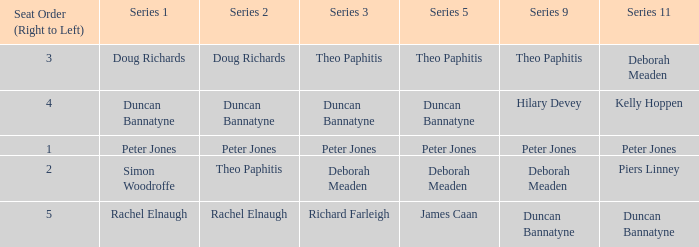Which series 1 includes a series 11 with peter jones? Peter Jones. 